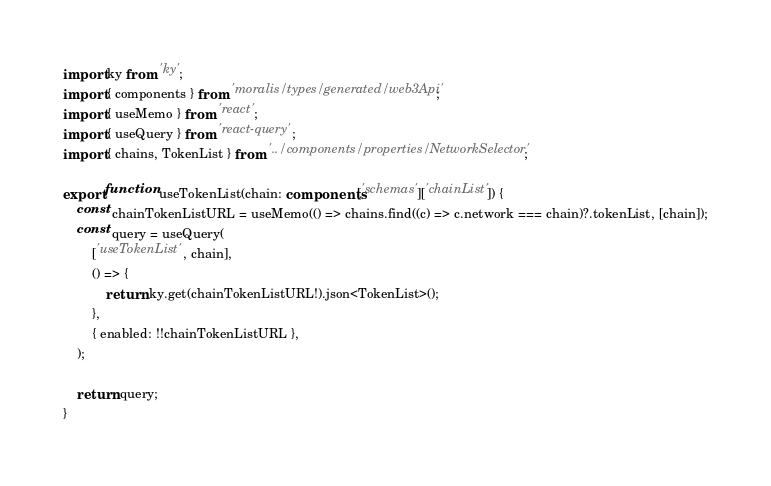<code> <loc_0><loc_0><loc_500><loc_500><_TypeScript_>import ky from 'ky';
import { components } from 'moralis/types/generated/web3Api';
import { useMemo } from 'react';
import { useQuery } from 'react-query';
import { chains, TokenList } from '../components/properties/NetworkSelector';

export function useTokenList(chain: components['schemas']['chainList']) {
	const chainTokenListURL = useMemo(() => chains.find((c) => c.network === chain)?.tokenList, [chain]);
	const query = useQuery(
		['useTokenList', chain],
		() => {
			return ky.get(chainTokenListURL!).json<TokenList>();
		},
		{ enabled: !!chainTokenListURL },
	);

	return query;
}
</code> 